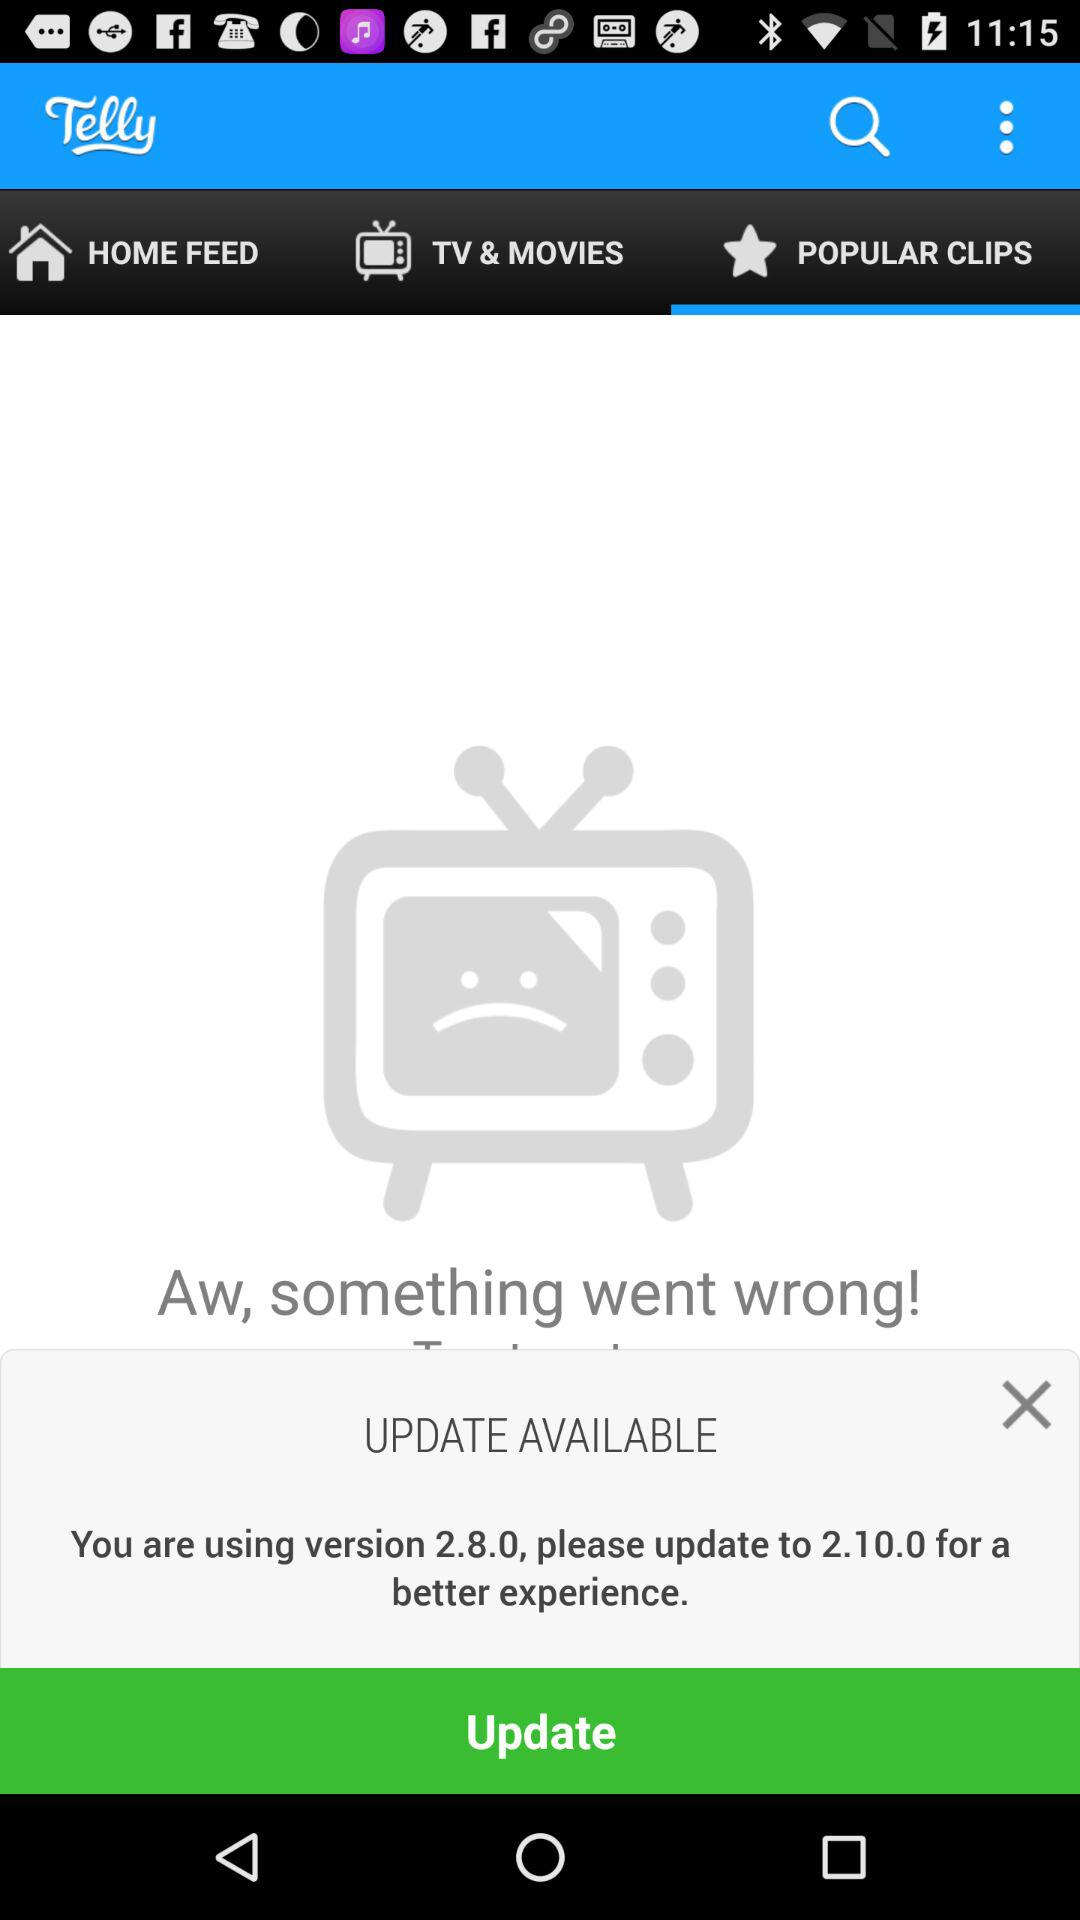What is the application name? The application name is "Telly". 